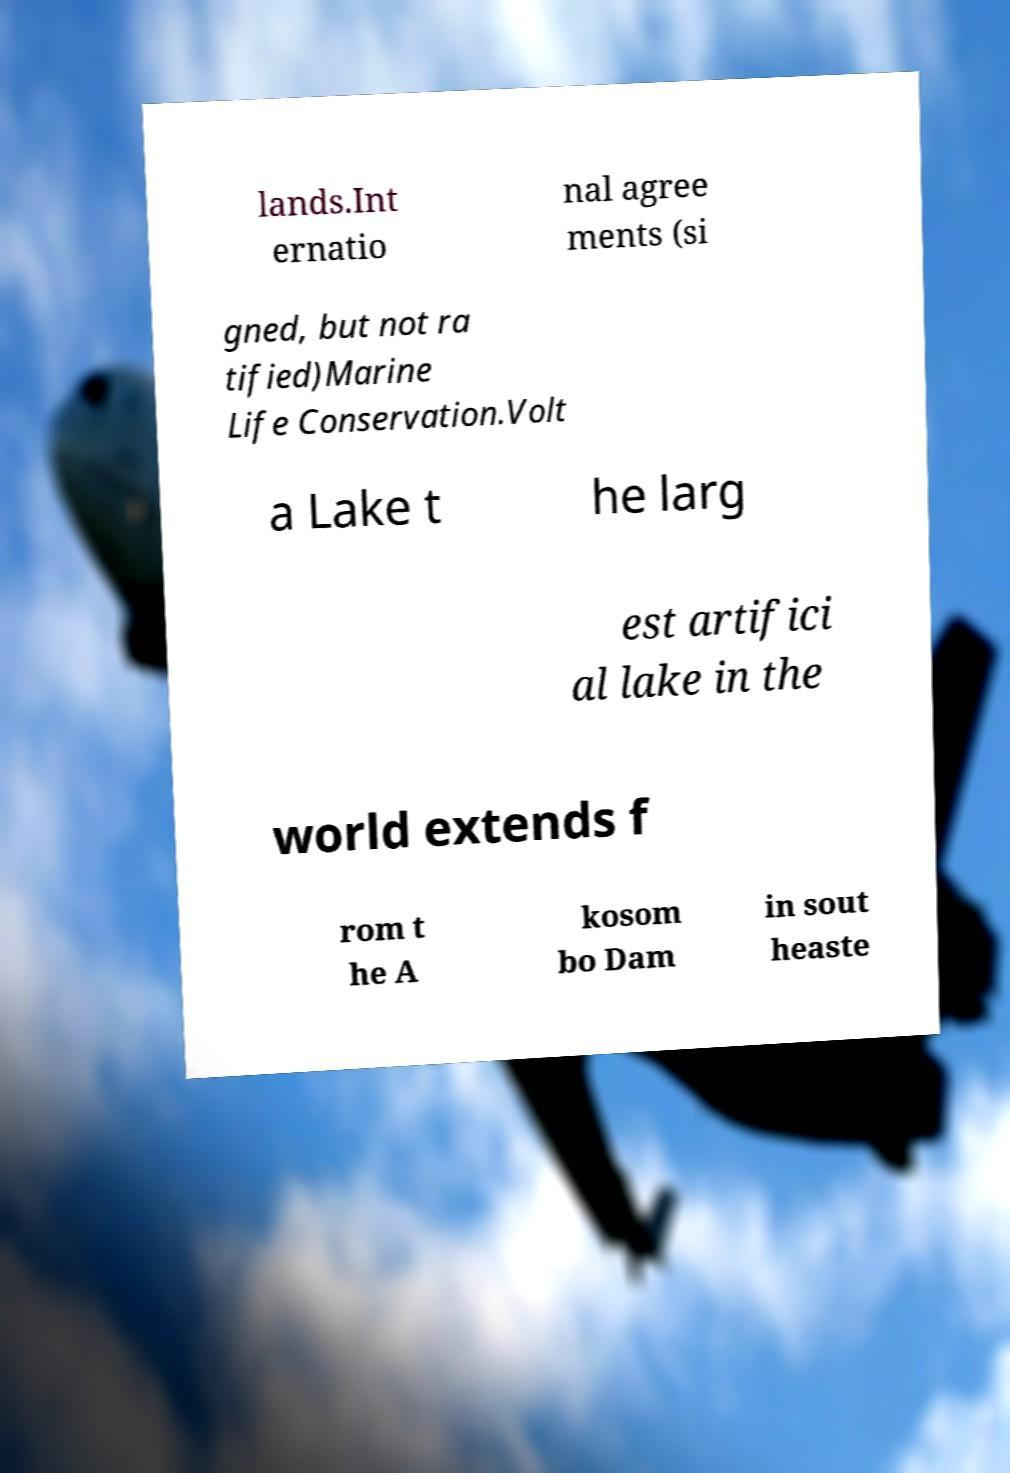Can you read and provide the text displayed in the image?This photo seems to have some interesting text. Can you extract and type it out for me? lands.Int ernatio nal agree ments (si gned, but not ra tified)Marine Life Conservation.Volt a Lake t he larg est artifici al lake in the world extends f rom t he A kosom bo Dam in sout heaste 